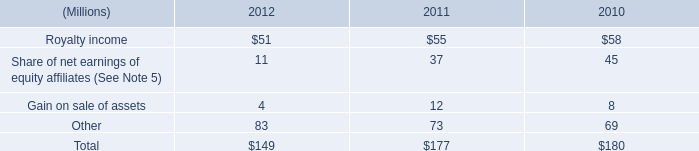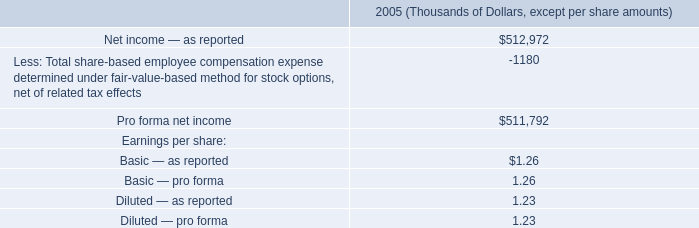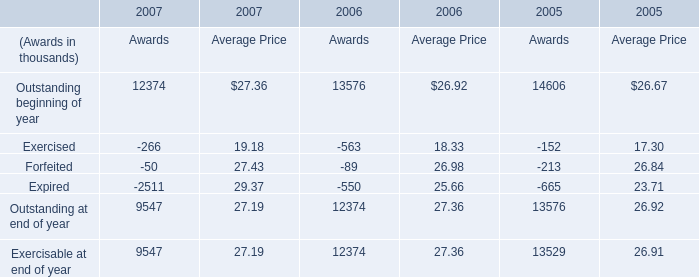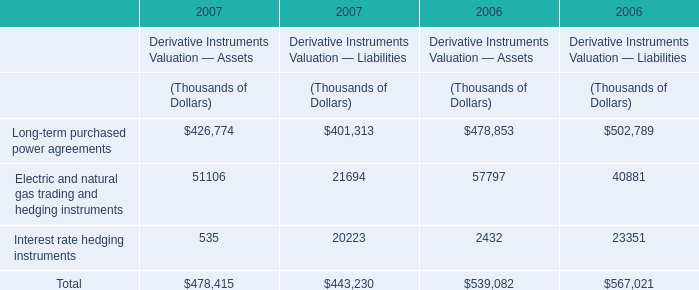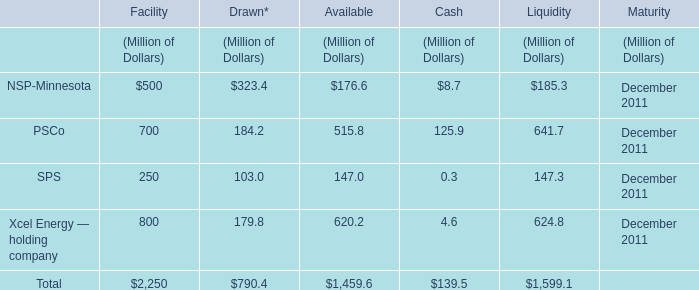What is the sum of the Sps in 2011 where NSP-Minnesota is positive? (in million) 
Computations: ((((250 + 103) + 147) + 0.3) + 147.3)
Answer: 647.6. 